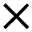Convert formula to latex. <formula><loc_0><loc_0><loc_500><loc_500>\times</formula> 